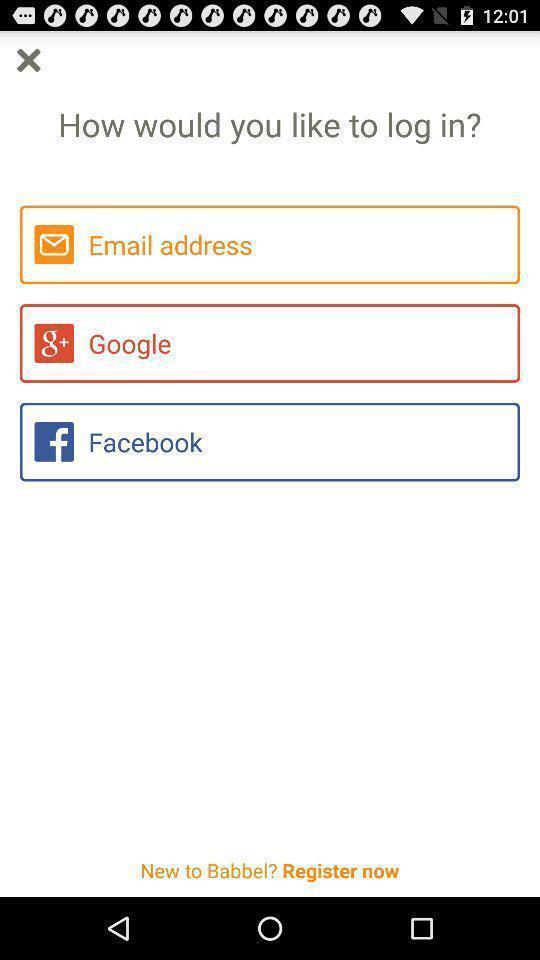What details can you identify in this image? Page is showing options to login. 